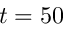Convert formula to latex. <formula><loc_0><loc_0><loc_500><loc_500>t = 5 0</formula> 